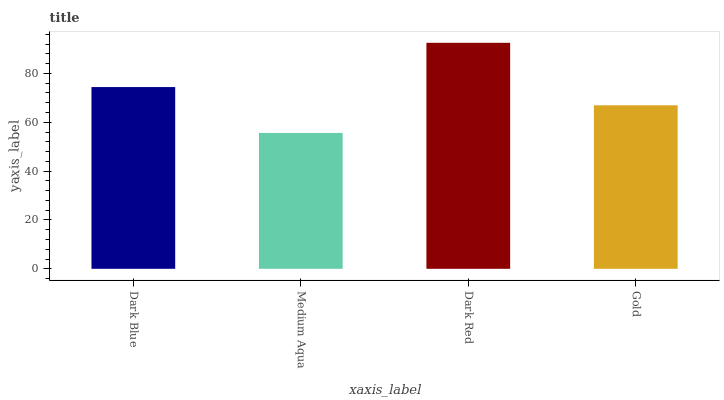Is Medium Aqua the minimum?
Answer yes or no. Yes. Is Dark Red the maximum?
Answer yes or no. Yes. Is Dark Red the minimum?
Answer yes or no. No. Is Medium Aqua the maximum?
Answer yes or no. No. Is Dark Red greater than Medium Aqua?
Answer yes or no. Yes. Is Medium Aqua less than Dark Red?
Answer yes or no. Yes. Is Medium Aqua greater than Dark Red?
Answer yes or no. No. Is Dark Red less than Medium Aqua?
Answer yes or no. No. Is Dark Blue the high median?
Answer yes or no. Yes. Is Gold the low median?
Answer yes or no. Yes. Is Medium Aqua the high median?
Answer yes or no. No. Is Dark Blue the low median?
Answer yes or no. No. 